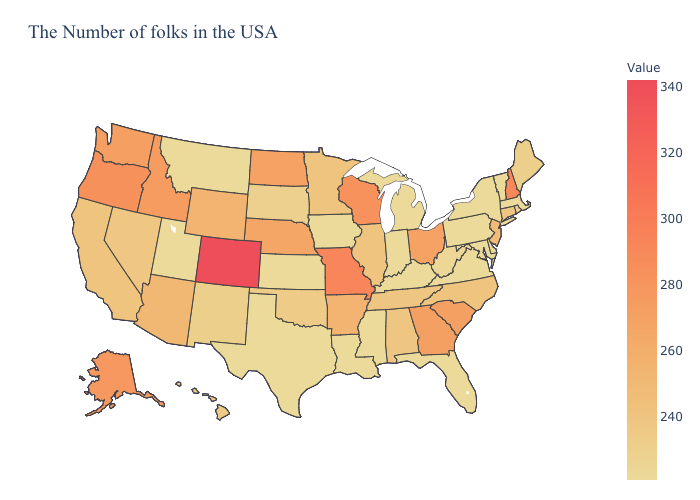Which states hav the highest value in the Northeast?
Quick response, please. New Hampshire. Among the states that border Michigan , which have the highest value?
Keep it brief. Wisconsin. Which states have the lowest value in the USA?
Be succinct. Massachusetts, Vermont, New York, Delaware, Maryland, Pennsylvania, Virginia, Florida, Michigan, Kentucky, Indiana, Mississippi, Louisiana, Iowa, Kansas, Texas, Utah, Montana. Among the states that border North Carolina , which have the highest value?
Short answer required. South Carolina, Georgia. Does Missouri have the lowest value in the MidWest?
Write a very short answer. No. Which states have the lowest value in the MidWest?
Concise answer only. Michigan, Indiana, Iowa, Kansas. Does Wisconsin have the lowest value in the MidWest?
Write a very short answer. No. Is the legend a continuous bar?
Quick response, please. Yes. 